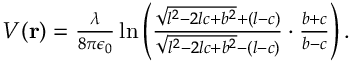Convert formula to latex. <formula><loc_0><loc_0><loc_500><loc_500>\begin{array} { r } { V ( r ) = \frac { \lambda } { 8 \pi \epsilon _ { 0 } } \ln \left ( \frac { \sqrt { l ^ { 2 } - 2 l c + b ^ { 2 } } + ( l - c ) } { \sqrt { l ^ { 2 } - 2 l c + b ^ { 2 } } - ( l - c ) } \cdot \frac { b + c } { b - c } \right ) . } \end{array}</formula> 